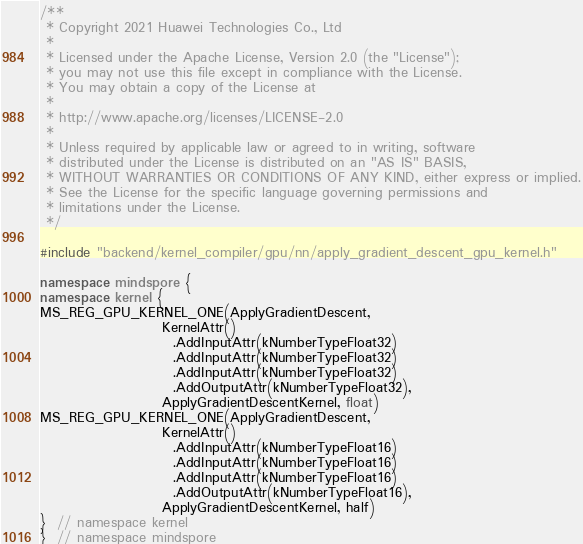Convert code to text. <code><loc_0><loc_0><loc_500><loc_500><_C++_>/**
 * Copyright 2021 Huawei Technologies Co., Ltd
 *
 * Licensed under the Apache License, Version 2.0 (the "License");
 * you may not use this file except in compliance with the License.
 * You may obtain a copy of the License at
 *
 * http://www.apache.org/licenses/LICENSE-2.0
 *
 * Unless required by applicable law or agreed to in writing, software
 * distributed under the License is distributed on an "AS IS" BASIS,
 * WITHOUT WARRANTIES OR CONDITIONS OF ANY KIND, either express or implied.
 * See the License for the specific language governing permissions and
 * limitations under the License.
 */

#include "backend/kernel_compiler/gpu/nn/apply_gradient_descent_gpu_kernel.h"

namespace mindspore {
namespace kernel {
MS_REG_GPU_KERNEL_ONE(ApplyGradientDescent,
                      KernelAttr()
                        .AddInputAttr(kNumberTypeFloat32)
                        .AddInputAttr(kNumberTypeFloat32)
                        .AddInputAttr(kNumberTypeFloat32)
                        .AddOutputAttr(kNumberTypeFloat32),
                      ApplyGradientDescentKernel, float)
MS_REG_GPU_KERNEL_ONE(ApplyGradientDescent,
                      KernelAttr()
                        .AddInputAttr(kNumberTypeFloat16)
                        .AddInputAttr(kNumberTypeFloat16)
                        .AddInputAttr(kNumberTypeFloat16)
                        .AddOutputAttr(kNumberTypeFloat16),
                      ApplyGradientDescentKernel, half)
}  // namespace kernel
}  // namespace mindspore
</code> 